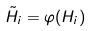Convert formula to latex. <formula><loc_0><loc_0><loc_500><loc_500>\tilde { H _ { i } } = \varphi ( H _ { i } )</formula> 